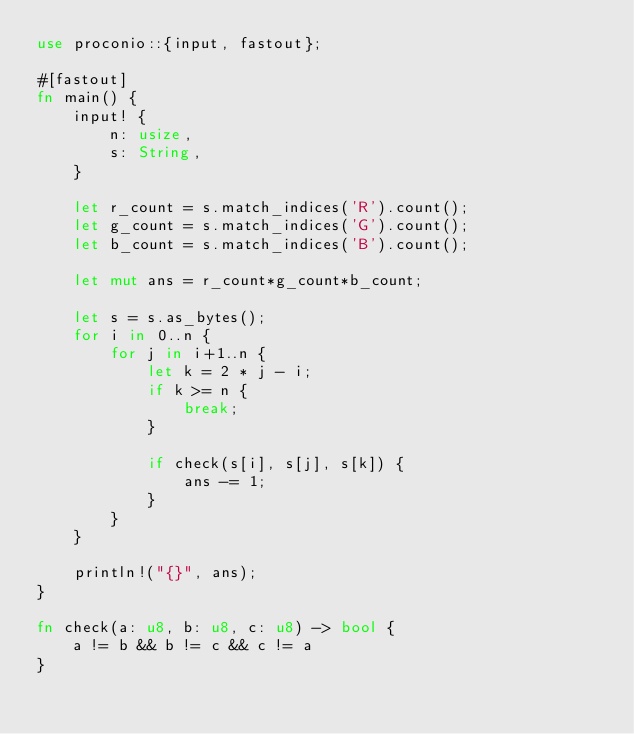Convert code to text. <code><loc_0><loc_0><loc_500><loc_500><_Rust_>use proconio::{input, fastout};

#[fastout]
fn main() {
    input! {
        n: usize,
        s: String,
    }

    let r_count = s.match_indices('R').count();
    let g_count = s.match_indices('G').count();
    let b_count = s.match_indices('B').count();

    let mut ans = r_count*g_count*b_count;

    let s = s.as_bytes();
    for i in 0..n {
        for j in i+1..n {
            let k = 2 * j - i;
            if k >= n {
                break;
            }

            if check(s[i], s[j], s[k]) {
                ans -= 1;
            }
        }
    }

    println!("{}", ans);
}

fn check(a: u8, b: u8, c: u8) -> bool {
    a != b && b != c && c != a
}</code> 